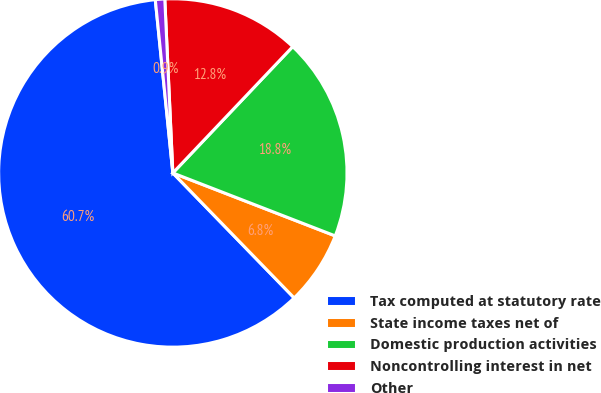<chart> <loc_0><loc_0><loc_500><loc_500><pie_chart><fcel>Tax computed at statutory rate<fcel>State income taxes net of<fcel>Domestic production activities<fcel>Noncontrolling interest in net<fcel>Other<nl><fcel>60.66%<fcel>6.85%<fcel>18.8%<fcel>12.82%<fcel>0.87%<nl></chart> 